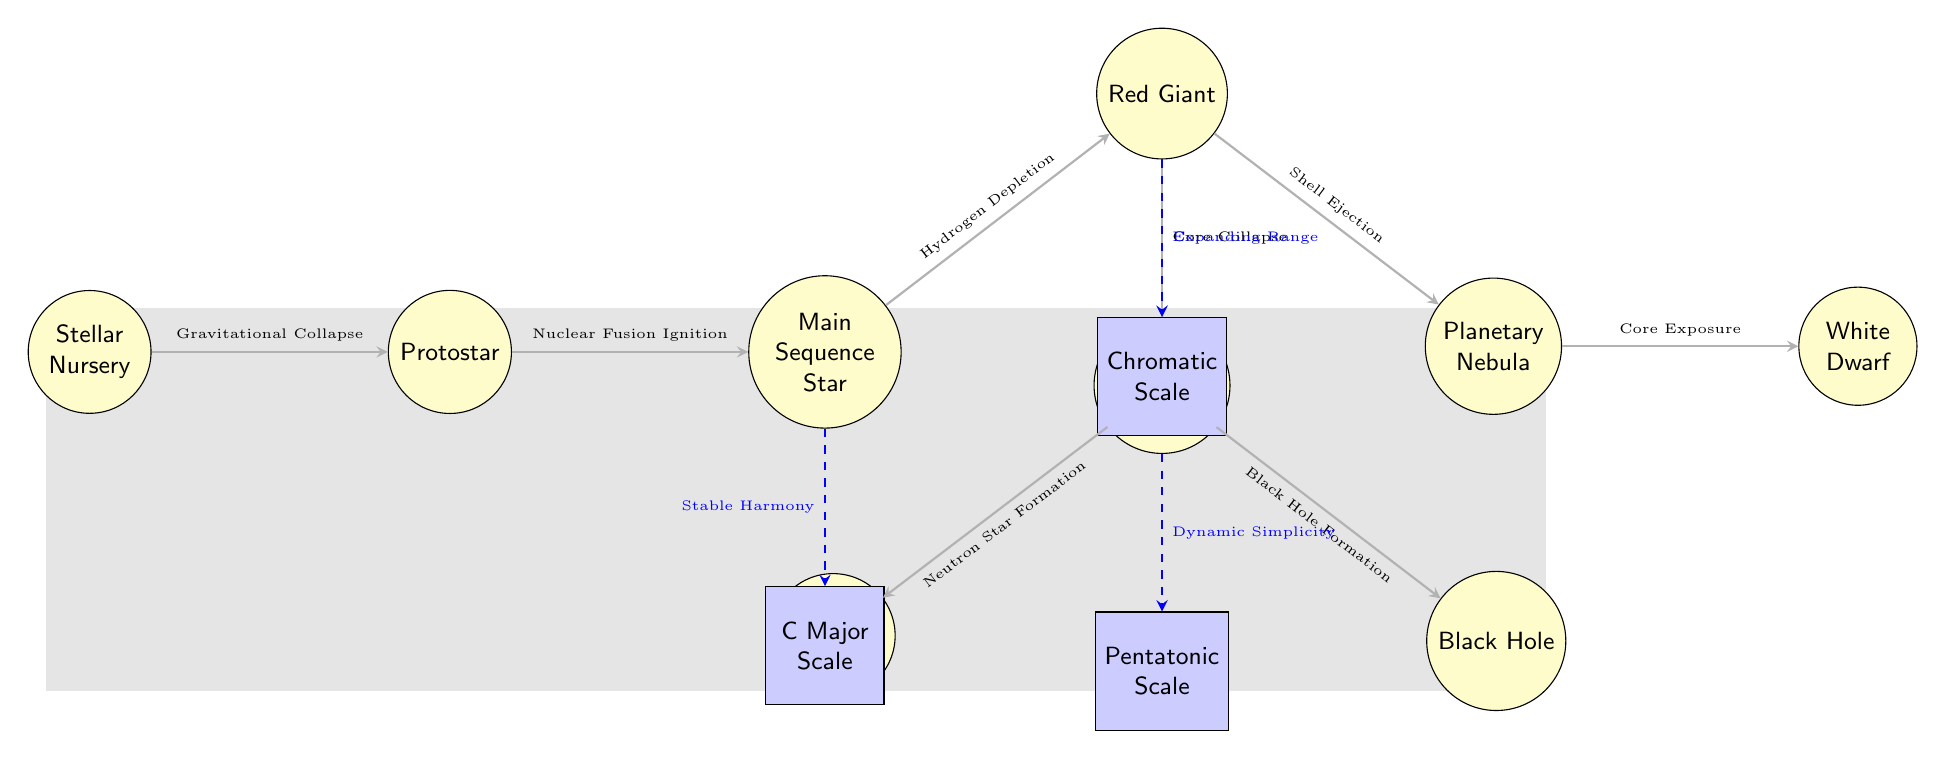What is the first stage of stellar evolution? The diagram starts with "Stellar Nursery" as the first node in the flow of stellar evolution. This is the initial stage where stars begin to form.
Answer: Stellar Nursery What follows the Protostar in the evolutionary sequence? The edge connecting Protostar to Main Sequence Star indicates that the next stage after Protostar is Main Sequence Star.
Answer: Main Sequence Star How many main star types are represented in the diagram? Counting all the distinct star types in the diagram, we identify Stellar Nursery, Protostar, Main Sequence Star, Red Giant, Planetary Nebula, White Dwarf, Supernova, Neutron Star, and Black Hole, resulting in a total of 9 star types.
Answer: 9 What musical scale is associated with the Main Sequence Star? The diagram shows a dashed connection from Main Sequence Star to C Major Scale, indicating that this particular musical scale is associated with Main Sequence Stars.
Answer: C Major Scale Which stellar phase involves Core Collapse? The diagram indicates that Red Giant transitions to Supernova through Core Collapse, showing this relationship clearly. Thus, Core Collapse is related to Red Giant leading to Supernova.
Answer: Red Giant What type of music connection is depicted under the Supernova phase? The diagram shows a dashed connection from Supernova to Pentatonic Scale, which describes the music connection under the Supernova phase specifically as "Dynamic Simplicity."
Answer: Pentatonic Scale Which type of star transforms into a Planetary Nebula? Looking at the diagram, the Red Giant leads to Planetary Nebula through Shell Ejection, indicating Red Giant transforms into a Planetary Nebula.
Answer: Red Giant What does the edge connecting Red Giant to Supernova represent? The edge denotes that the process transitioning from Red Giant to Supernova is defined as Core Collapse, which signifies a critical evolutionary step.
Answer: Core Collapse What is the last stage of stellar evolution depicted in the diagram? The most downstream node in the diagram after all transformations and evolution is the Black Hole, indicating it is the final stage in this sequence of stellar evolution.
Answer: Black Hole 